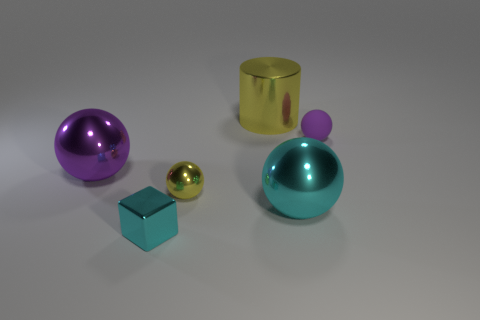What number of shiny objects are the same color as the small cube? Upon carefully observing the image, there's only one shiny object which shares the same hue of aqua or turquoise as the small cube, and that would be the spherical object with the small stand on top. 